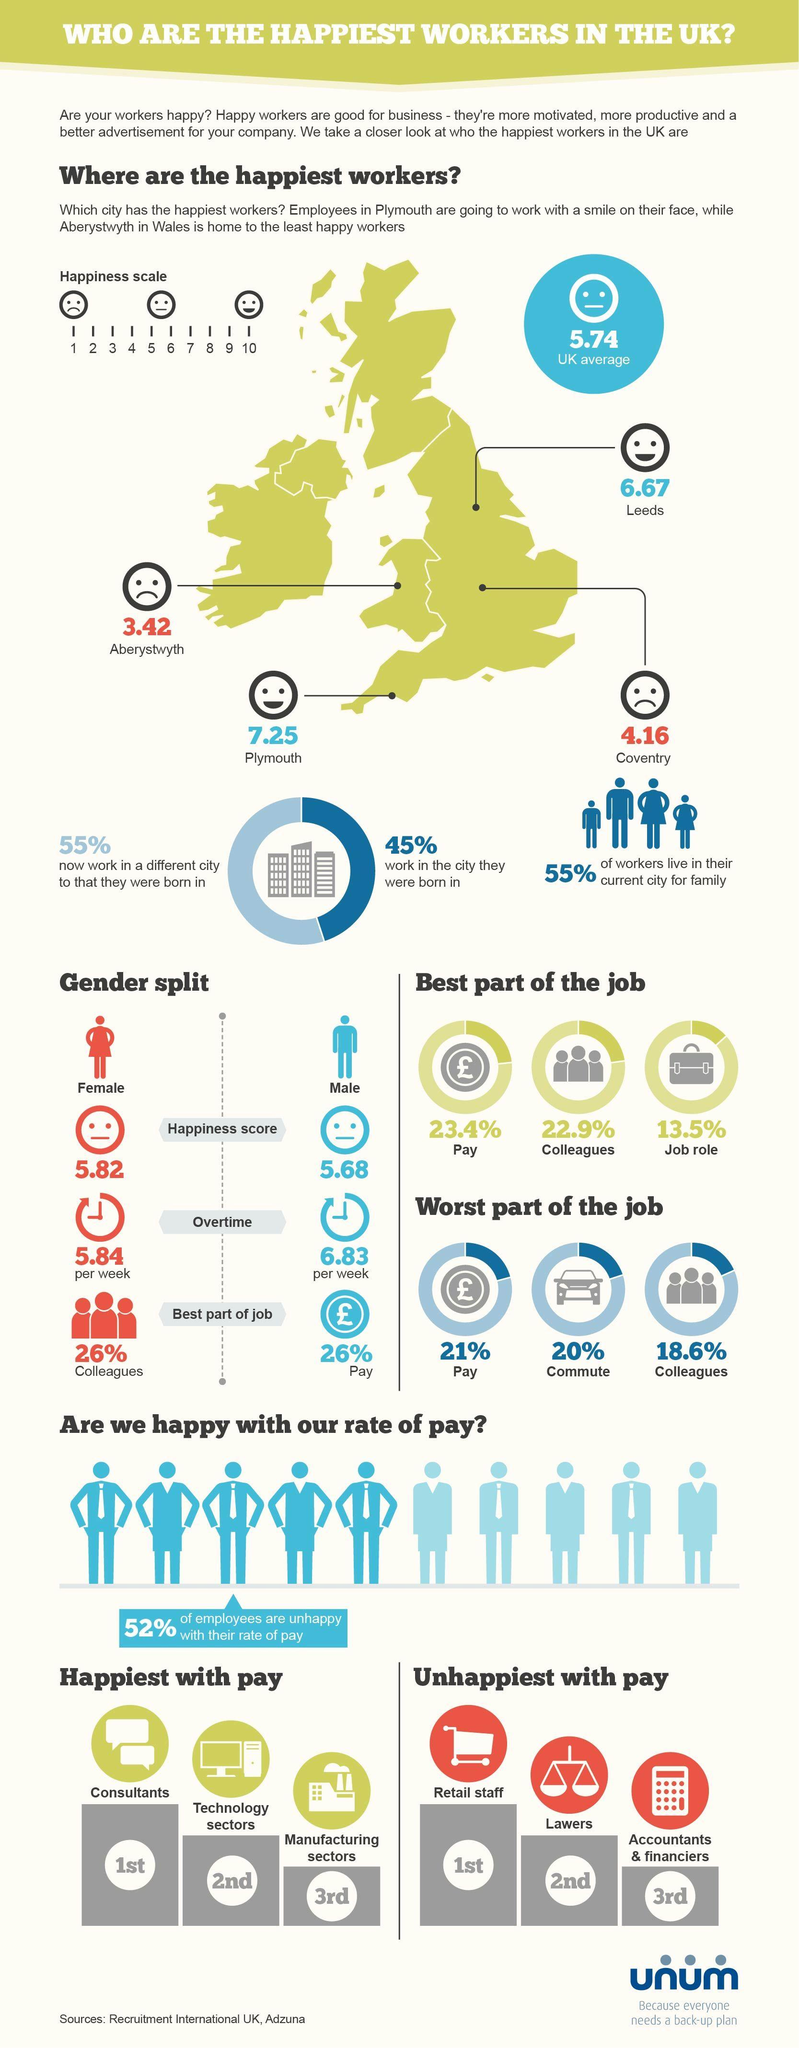List a handful of essential elements in this visual. Pay is the best and worst aspect of the job for the majority of people in a given profession. It is generally believed that females have a higher happiness score than males. Consultants are generally considered to be the happiest with their pay among all professions. The male gender typically performs more overtime work than the female gender. According to the survey, 48% of employees are satisfied with their current rate of pay. 